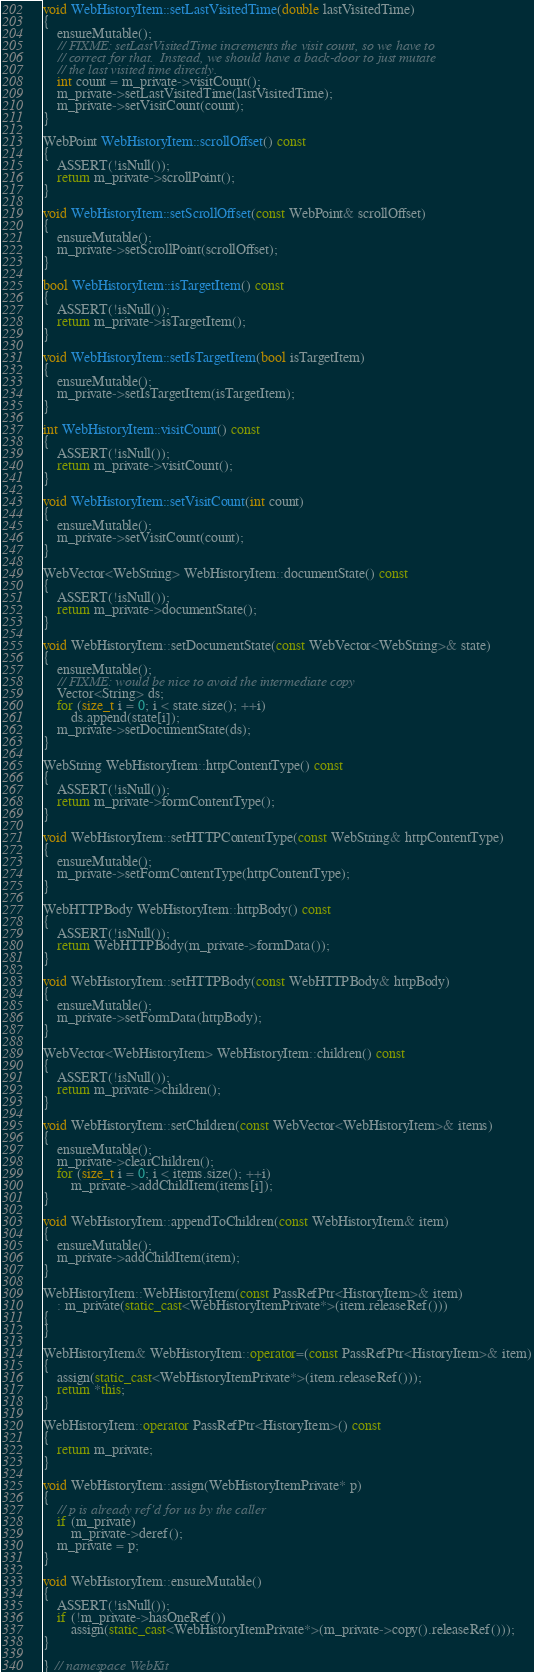Convert code to text. <code><loc_0><loc_0><loc_500><loc_500><_C++_>void WebHistoryItem::setLastVisitedTime(double lastVisitedTime)
{
    ensureMutable();
    // FIXME: setLastVisitedTime increments the visit count, so we have to
    // correct for that.  Instead, we should have a back-door to just mutate
    // the last visited time directly.
    int count = m_private->visitCount();
    m_private->setLastVisitedTime(lastVisitedTime);
    m_private->setVisitCount(count);
}

WebPoint WebHistoryItem::scrollOffset() const
{
    ASSERT(!isNull());
    return m_private->scrollPoint();
}

void WebHistoryItem::setScrollOffset(const WebPoint& scrollOffset)
{
    ensureMutable();
    m_private->setScrollPoint(scrollOffset);
}

bool WebHistoryItem::isTargetItem() const
{
    ASSERT(!isNull());
    return m_private->isTargetItem();
}

void WebHistoryItem::setIsTargetItem(bool isTargetItem)
{
    ensureMutable();
    m_private->setIsTargetItem(isTargetItem);
}

int WebHistoryItem::visitCount() const
{
    ASSERT(!isNull());
    return m_private->visitCount();
}

void WebHistoryItem::setVisitCount(int count)
{
    ensureMutable();
    m_private->setVisitCount(count);
}

WebVector<WebString> WebHistoryItem::documentState() const
{
    ASSERT(!isNull());
    return m_private->documentState();
}

void WebHistoryItem::setDocumentState(const WebVector<WebString>& state)
{
    ensureMutable();
    // FIXME: would be nice to avoid the intermediate copy
    Vector<String> ds;
    for (size_t i = 0; i < state.size(); ++i)
        ds.append(state[i]);
    m_private->setDocumentState(ds);
}

WebString WebHistoryItem::httpContentType() const
{
    ASSERT(!isNull());
    return m_private->formContentType();
}

void WebHistoryItem::setHTTPContentType(const WebString& httpContentType)
{
    ensureMutable();
    m_private->setFormContentType(httpContentType);
}

WebHTTPBody WebHistoryItem::httpBody() const
{
    ASSERT(!isNull());
    return WebHTTPBody(m_private->formData());
}

void WebHistoryItem::setHTTPBody(const WebHTTPBody& httpBody)
{
    ensureMutable();
    m_private->setFormData(httpBody);
}

WebVector<WebHistoryItem> WebHistoryItem::children() const
{
    ASSERT(!isNull());
    return m_private->children();
}

void WebHistoryItem::setChildren(const WebVector<WebHistoryItem>& items)
{
    ensureMutable();
    m_private->clearChildren();
    for (size_t i = 0; i < items.size(); ++i)
        m_private->addChildItem(items[i]);
}

void WebHistoryItem::appendToChildren(const WebHistoryItem& item)
{
    ensureMutable();
    m_private->addChildItem(item);
}

WebHistoryItem::WebHistoryItem(const PassRefPtr<HistoryItem>& item)
    : m_private(static_cast<WebHistoryItemPrivate*>(item.releaseRef()))
{
}

WebHistoryItem& WebHistoryItem::operator=(const PassRefPtr<HistoryItem>& item)
{
    assign(static_cast<WebHistoryItemPrivate*>(item.releaseRef()));
    return *this;
}

WebHistoryItem::operator PassRefPtr<HistoryItem>() const
{
    return m_private;
}

void WebHistoryItem::assign(WebHistoryItemPrivate* p)
{
    // p is already ref'd for us by the caller
    if (m_private)
        m_private->deref();
    m_private = p;
}

void WebHistoryItem::ensureMutable()
{
    ASSERT(!isNull());
    if (!m_private->hasOneRef())
        assign(static_cast<WebHistoryItemPrivate*>(m_private->copy().releaseRef()));
}

} // namespace WebKit
</code> 